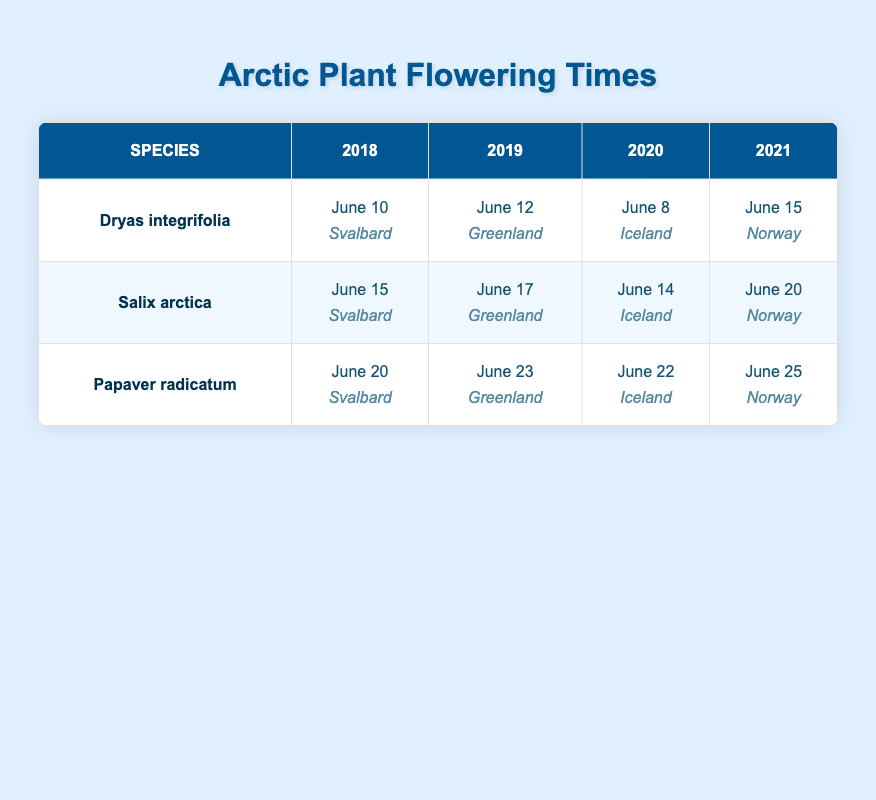What is the flowering date of Dryas integrifolia in 2019? To find this, I look at the row for Dryas integrifolia and then check the column for the year 2019. The flowering date listed there is June 12.
Answer: June 12 What location is associated with the flowering date of Salix arctica in 2020? I check the row for Salix arctica and find the column for the year 2020. The location listed for Salix arctica's flowering date is Iceland.
Answer: Iceland Did Papaver radicatum flower earlier in 2019 or 2020? To answer this, I compare the flowering dates for Papaver radicatum in both years. In 2019, it flowered on June 23, and in 2020, it flowered on June 22. Since June 22 comes before June 23, then it flowered earlier in 2020.
Answer: 2020 What is the average flowering date for Salix arctica across the years provided? I take the flowering dates for Salix arctica: June 15 (2018), June 17 (2019), June 14 (2020), and June 20 (2021). Counting them as ordinal days: June 15 is the 165th day, June 17 is the 167th, June 14 is the 166th, and June 20 is the 170th. The average is (165 + 167 + 166 + 170) / 4 = 167. The corresponding date is June 17.
Answer: June 17 Is it true that all species listed flower in June? I review the flowering dates for all species across the years and confirm that all flowering dates occur in June. Therefore, the statement is true.
Answer: Yes 